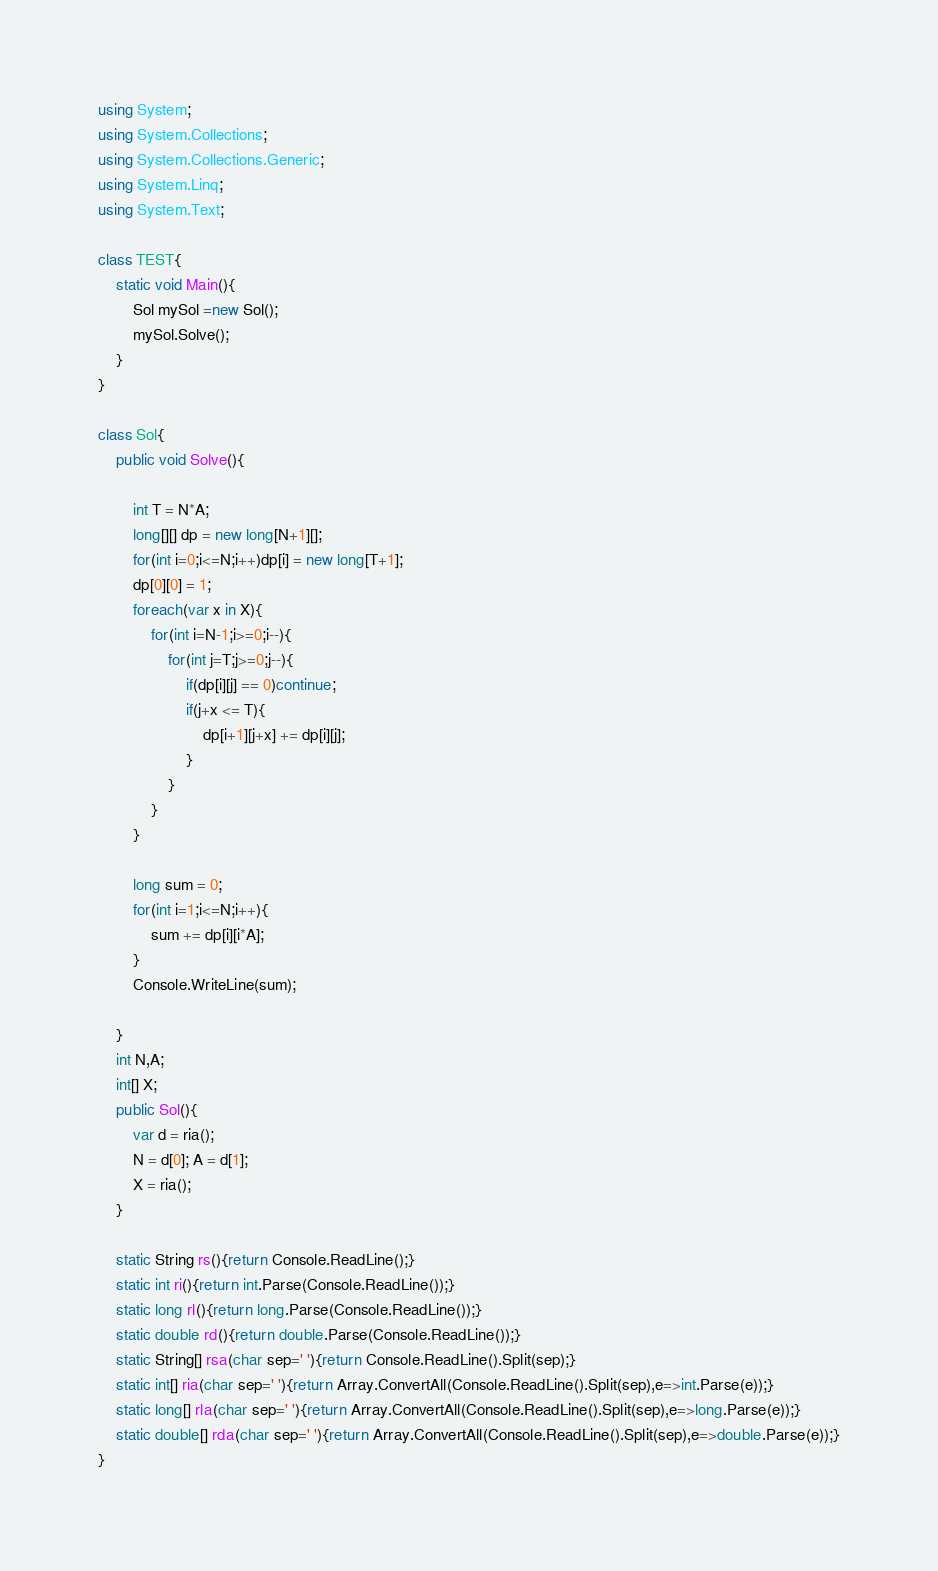Convert code to text. <code><loc_0><loc_0><loc_500><loc_500><_C#_>using System;
using System.Collections;
using System.Collections.Generic;
using System.Linq;
using System.Text;

class TEST{
	static void Main(){
		Sol mySol =new Sol();
		mySol.Solve();
	}
}

class Sol{
	public void Solve(){
		
		int T = N*A;
		long[][] dp = new long[N+1][];
		for(int i=0;i<=N;i++)dp[i] = new long[T+1];
		dp[0][0] = 1;
		foreach(var x in X){
			for(int i=N-1;i>=0;i--){
				for(int j=T;j>=0;j--){
					if(dp[i][j] == 0)continue;
					if(j+x <= T){
						dp[i+1][j+x] += dp[i][j];
					}
				}
			}
		}
		
		long sum = 0;
		for(int i=1;i<=N;i++){
			sum += dp[i][i*A];
		}
		Console.WriteLine(sum);
		
	}
	int N,A;
	int[] X;
	public Sol(){
		var d = ria();
		N = d[0]; A = d[1];
		X = ria();
	}

	static String rs(){return Console.ReadLine();}
	static int ri(){return int.Parse(Console.ReadLine());}
	static long rl(){return long.Parse(Console.ReadLine());}
	static double rd(){return double.Parse(Console.ReadLine());}
	static String[] rsa(char sep=' '){return Console.ReadLine().Split(sep);}
	static int[] ria(char sep=' '){return Array.ConvertAll(Console.ReadLine().Split(sep),e=>int.Parse(e));}
	static long[] rla(char sep=' '){return Array.ConvertAll(Console.ReadLine().Split(sep),e=>long.Parse(e));}
	static double[] rda(char sep=' '){return Array.ConvertAll(Console.ReadLine().Split(sep),e=>double.Parse(e));}
}
</code> 